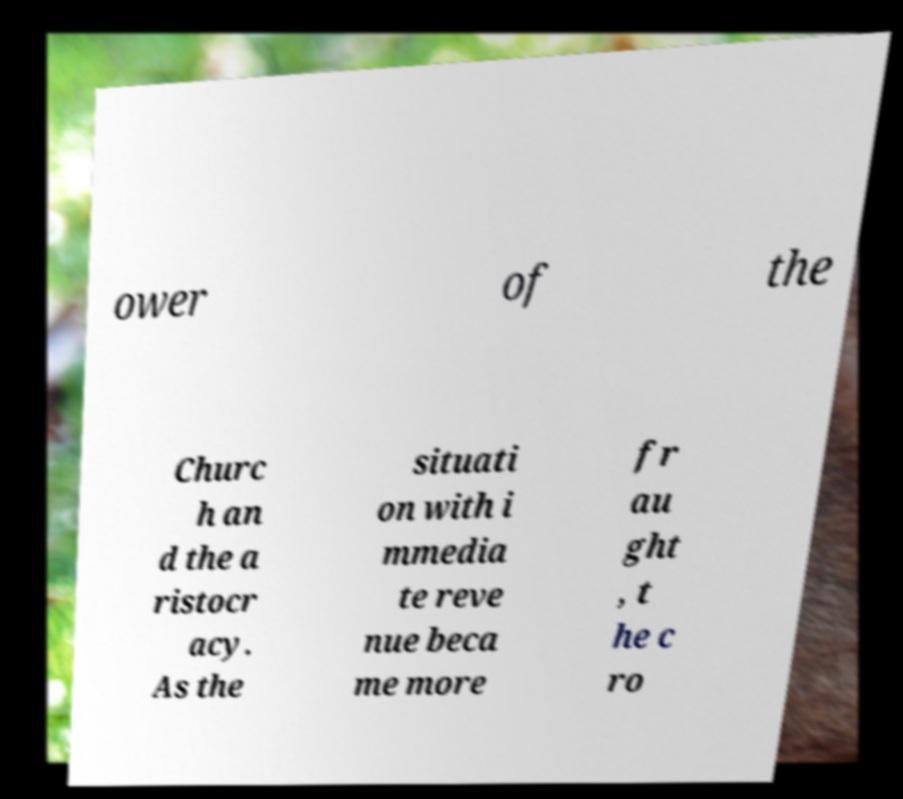I need the written content from this picture converted into text. Can you do that? ower of the Churc h an d the a ristocr acy. As the situati on with i mmedia te reve nue beca me more fr au ght , t he c ro 